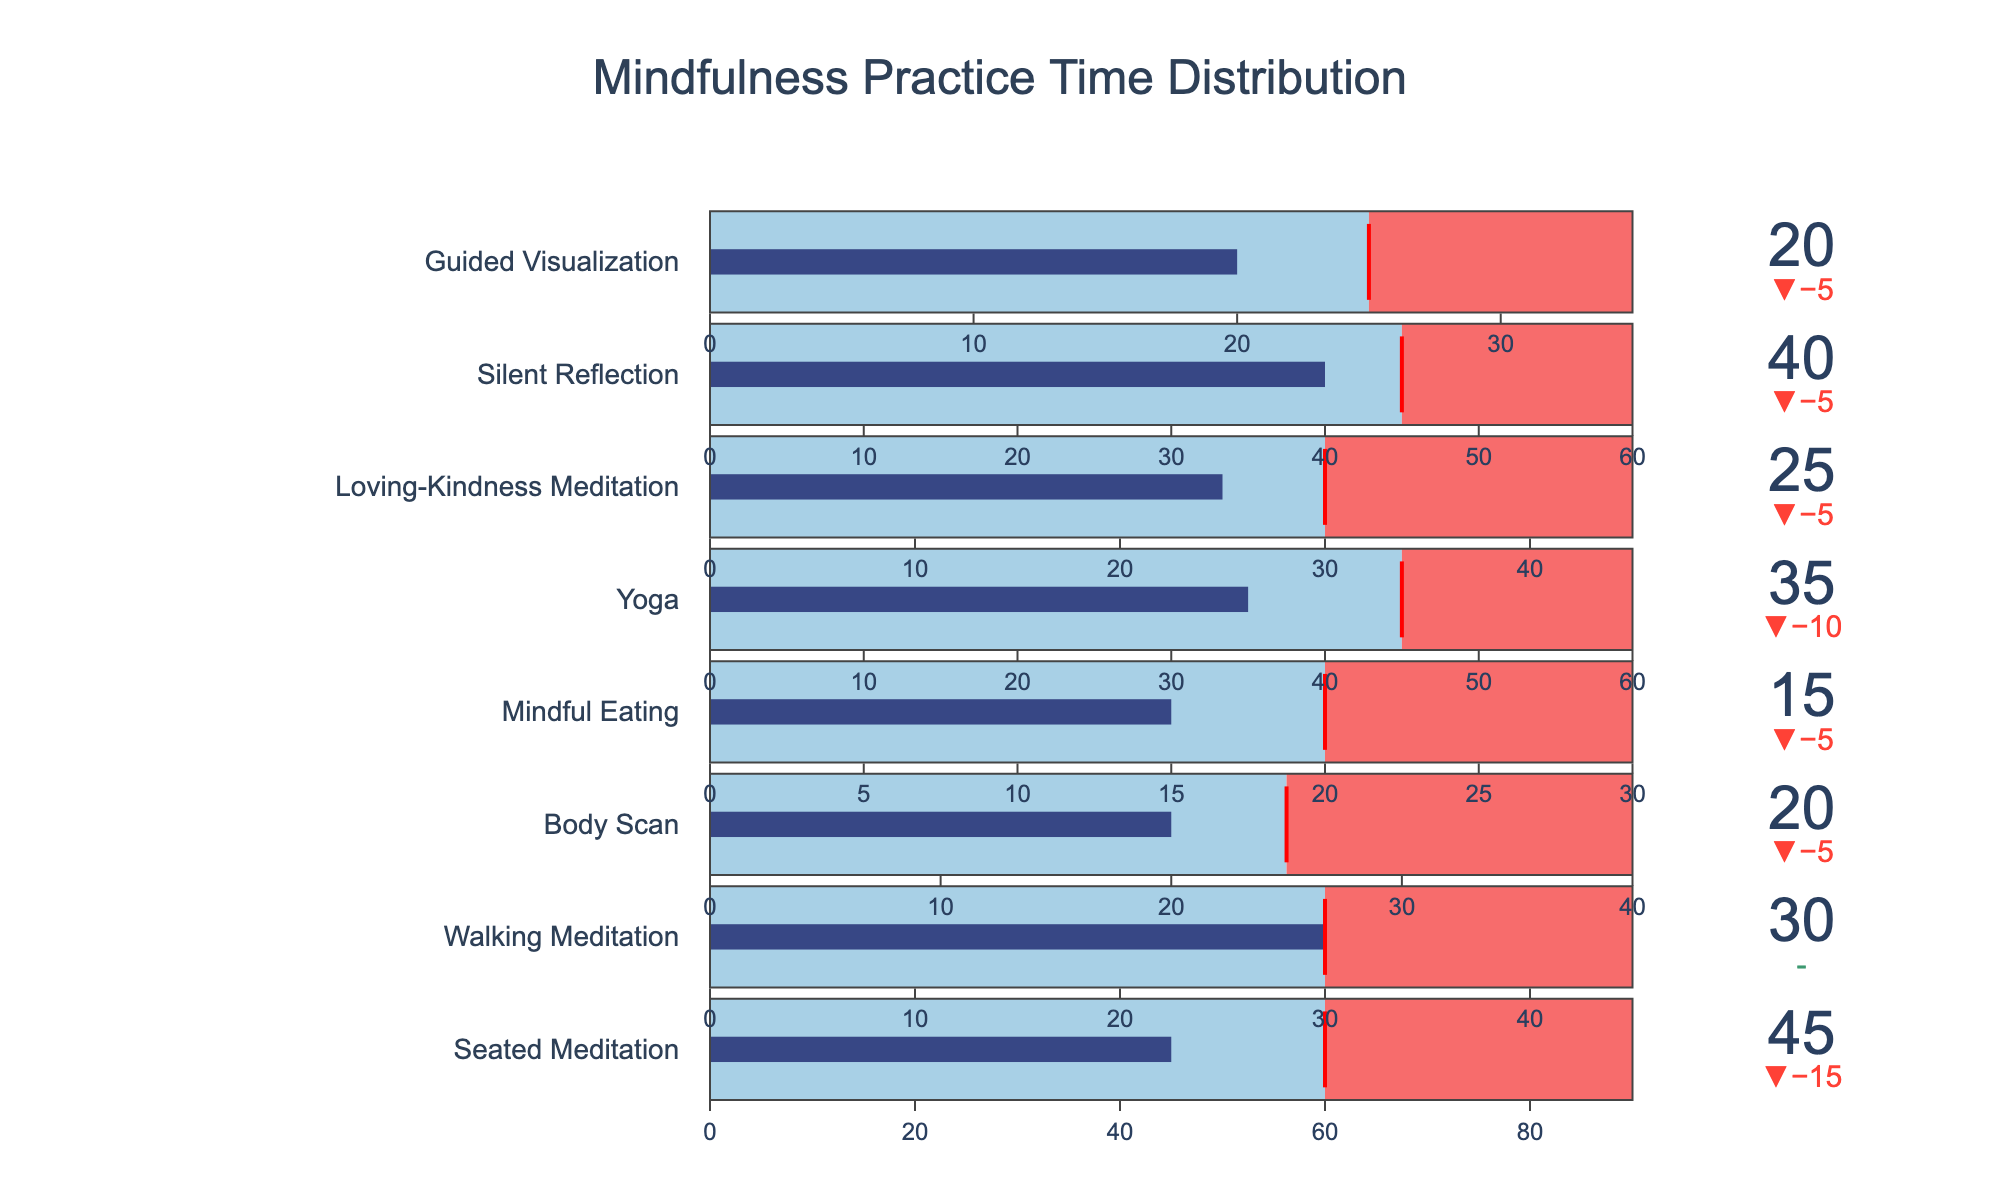what is the title of the figure? The title of the figure helps to understand the overall topic or data being visualized. Look at the top of the figure for the title text.
Answer: Mindfulness Practice Time Distribution What is the recommended duration for Seated Meditation? Refer to the gauge representing Seated Meditation, there is a threshold line indicating the recommended duration.
Answer: 60 Which practice type has the highest maximum duration? Compare the maximum duration values on the gauge for each practice type to find the highest one.
Answer: Seated Meditation How much less is the actual time spent on Yoga compared to the recommended time? Subtract the actual time spent on Yoga from its recommended time: 45 - 35.
Answer: 10 Which practice type exactly meets its recommended duration? Look for the gauge that has the bar indicator exactly at the threshold line for the recommended time.
Answer: Walking Meditation What is the total maximum duration for all practice types combined? Sum the maximum minutes for all practice types: 90 (Seated Meditation) + 45 (Walking Meditation) + 40 (Body Scan) + 30 (Mindful Eating) + 60 (Yoga) + 45 (Loving-Kindness Meditation) + 60 (Silent Reflection) + 35 (Guided Visualization).
Answer: 405 Which practice type has the smallest actual time compared to the recommended time? For each practice, calculate the difference between actual and recommended times, and find the smallest: 60-45, 30-30, 25-20, 20-15, 45-35, 30-25, 45-40, 25-20.
Answer: Mindful Eating How many practice types have actual durations less than their recommended durations? Count the practices where the actual minutes value is less than the recommended minutes value: Seated Meditation, Body Scan, Mindful Eating, Yoga, Loving-Kindness Meditation, Silent Reflection, Guided Visualization.
Answer: 7 What is the average actual practice time? Add all actual minutes and divide by the number of practices: (45 + 30 + 20 + 15 + 35 + 25 + 40 + 20) / 8.
Answer: 28.75 Which practice type has the smallest difference between actual and maximum time? Calculate the difference between actual and maximum minutes for each practice, and find the smallest: 90-45, 45-30, 40-20, 30-15, 60-35, 45-25, 60-40, 35-20.
Answer: Silent Reflection 